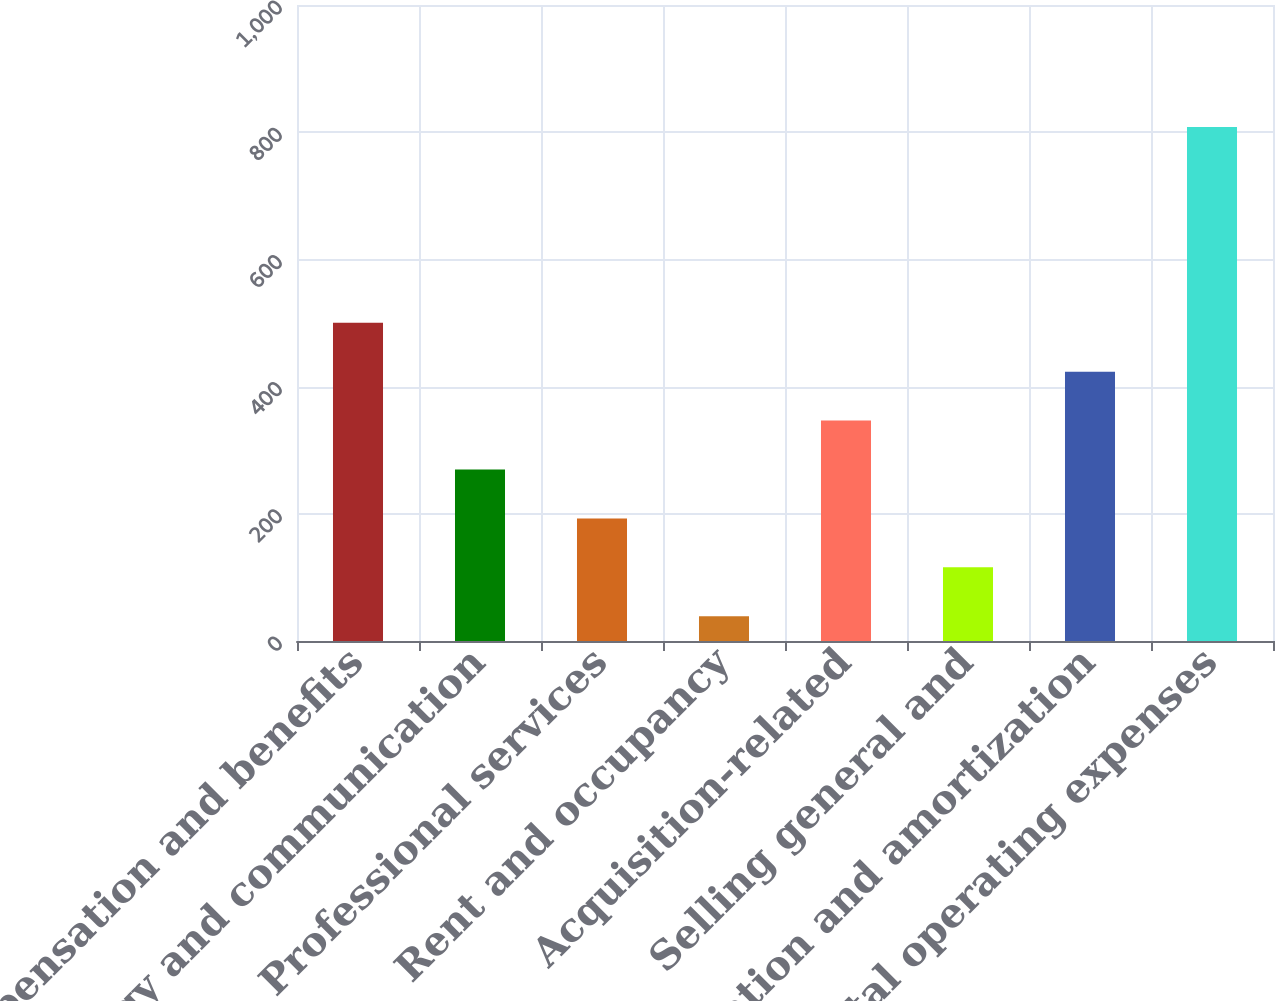Convert chart to OTSL. <chart><loc_0><loc_0><loc_500><loc_500><bar_chart><fcel>Compensation and benefits<fcel>Technology and communication<fcel>Professional services<fcel>Rent and occupancy<fcel>Acquisition-related<fcel>Selling general and<fcel>Depreciation and amortization<fcel>Total operating expenses<nl><fcel>500.4<fcel>269.7<fcel>192.8<fcel>39<fcel>346.6<fcel>115.9<fcel>423.5<fcel>808<nl></chart> 